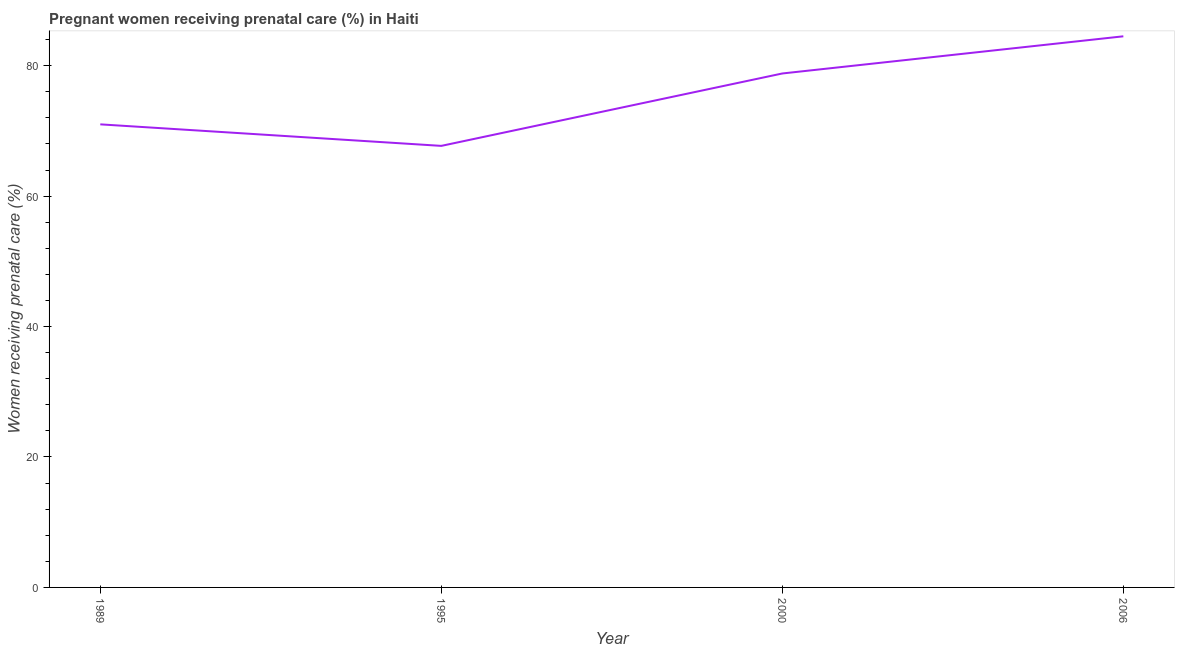What is the percentage of pregnant women receiving prenatal care in 1995?
Provide a succinct answer. 67.7. Across all years, what is the maximum percentage of pregnant women receiving prenatal care?
Provide a short and direct response. 84.5. Across all years, what is the minimum percentage of pregnant women receiving prenatal care?
Your answer should be very brief. 67.7. What is the sum of the percentage of pregnant women receiving prenatal care?
Offer a terse response. 302. What is the difference between the percentage of pregnant women receiving prenatal care in 1995 and 2000?
Give a very brief answer. -11.1. What is the average percentage of pregnant women receiving prenatal care per year?
Keep it short and to the point. 75.5. What is the median percentage of pregnant women receiving prenatal care?
Keep it short and to the point. 74.9. In how many years, is the percentage of pregnant women receiving prenatal care greater than 52 %?
Offer a very short reply. 4. What is the ratio of the percentage of pregnant women receiving prenatal care in 2000 to that in 2006?
Keep it short and to the point. 0.93. Is the difference between the percentage of pregnant women receiving prenatal care in 1995 and 2000 greater than the difference between any two years?
Offer a terse response. No. What is the difference between the highest and the second highest percentage of pregnant women receiving prenatal care?
Ensure brevity in your answer.  5.7. What is the difference between the highest and the lowest percentage of pregnant women receiving prenatal care?
Make the answer very short. 16.8. Does the percentage of pregnant women receiving prenatal care monotonically increase over the years?
Ensure brevity in your answer.  No. How many years are there in the graph?
Provide a short and direct response. 4. What is the difference between two consecutive major ticks on the Y-axis?
Your response must be concise. 20. Does the graph contain any zero values?
Your answer should be compact. No. Does the graph contain grids?
Ensure brevity in your answer.  No. What is the title of the graph?
Your answer should be compact. Pregnant women receiving prenatal care (%) in Haiti. What is the label or title of the X-axis?
Give a very brief answer. Year. What is the label or title of the Y-axis?
Give a very brief answer. Women receiving prenatal care (%). What is the Women receiving prenatal care (%) in 1995?
Give a very brief answer. 67.7. What is the Women receiving prenatal care (%) in 2000?
Make the answer very short. 78.8. What is the Women receiving prenatal care (%) in 2006?
Offer a very short reply. 84.5. What is the difference between the Women receiving prenatal care (%) in 1989 and 1995?
Ensure brevity in your answer.  3.3. What is the difference between the Women receiving prenatal care (%) in 1989 and 2006?
Offer a very short reply. -13.5. What is the difference between the Women receiving prenatal care (%) in 1995 and 2006?
Provide a short and direct response. -16.8. What is the difference between the Women receiving prenatal care (%) in 2000 and 2006?
Offer a very short reply. -5.7. What is the ratio of the Women receiving prenatal care (%) in 1989 to that in 1995?
Make the answer very short. 1.05. What is the ratio of the Women receiving prenatal care (%) in 1989 to that in 2000?
Offer a terse response. 0.9. What is the ratio of the Women receiving prenatal care (%) in 1989 to that in 2006?
Your response must be concise. 0.84. What is the ratio of the Women receiving prenatal care (%) in 1995 to that in 2000?
Keep it short and to the point. 0.86. What is the ratio of the Women receiving prenatal care (%) in 1995 to that in 2006?
Offer a very short reply. 0.8. What is the ratio of the Women receiving prenatal care (%) in 2000 to that in 2006?
Give a very brief answer. 0.93. 